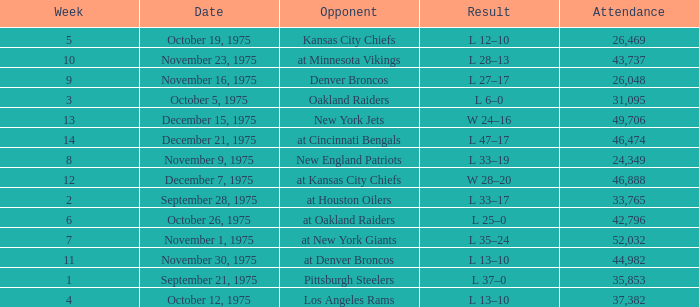What is the lowest Week when the result was l 6–0? 3.0. 